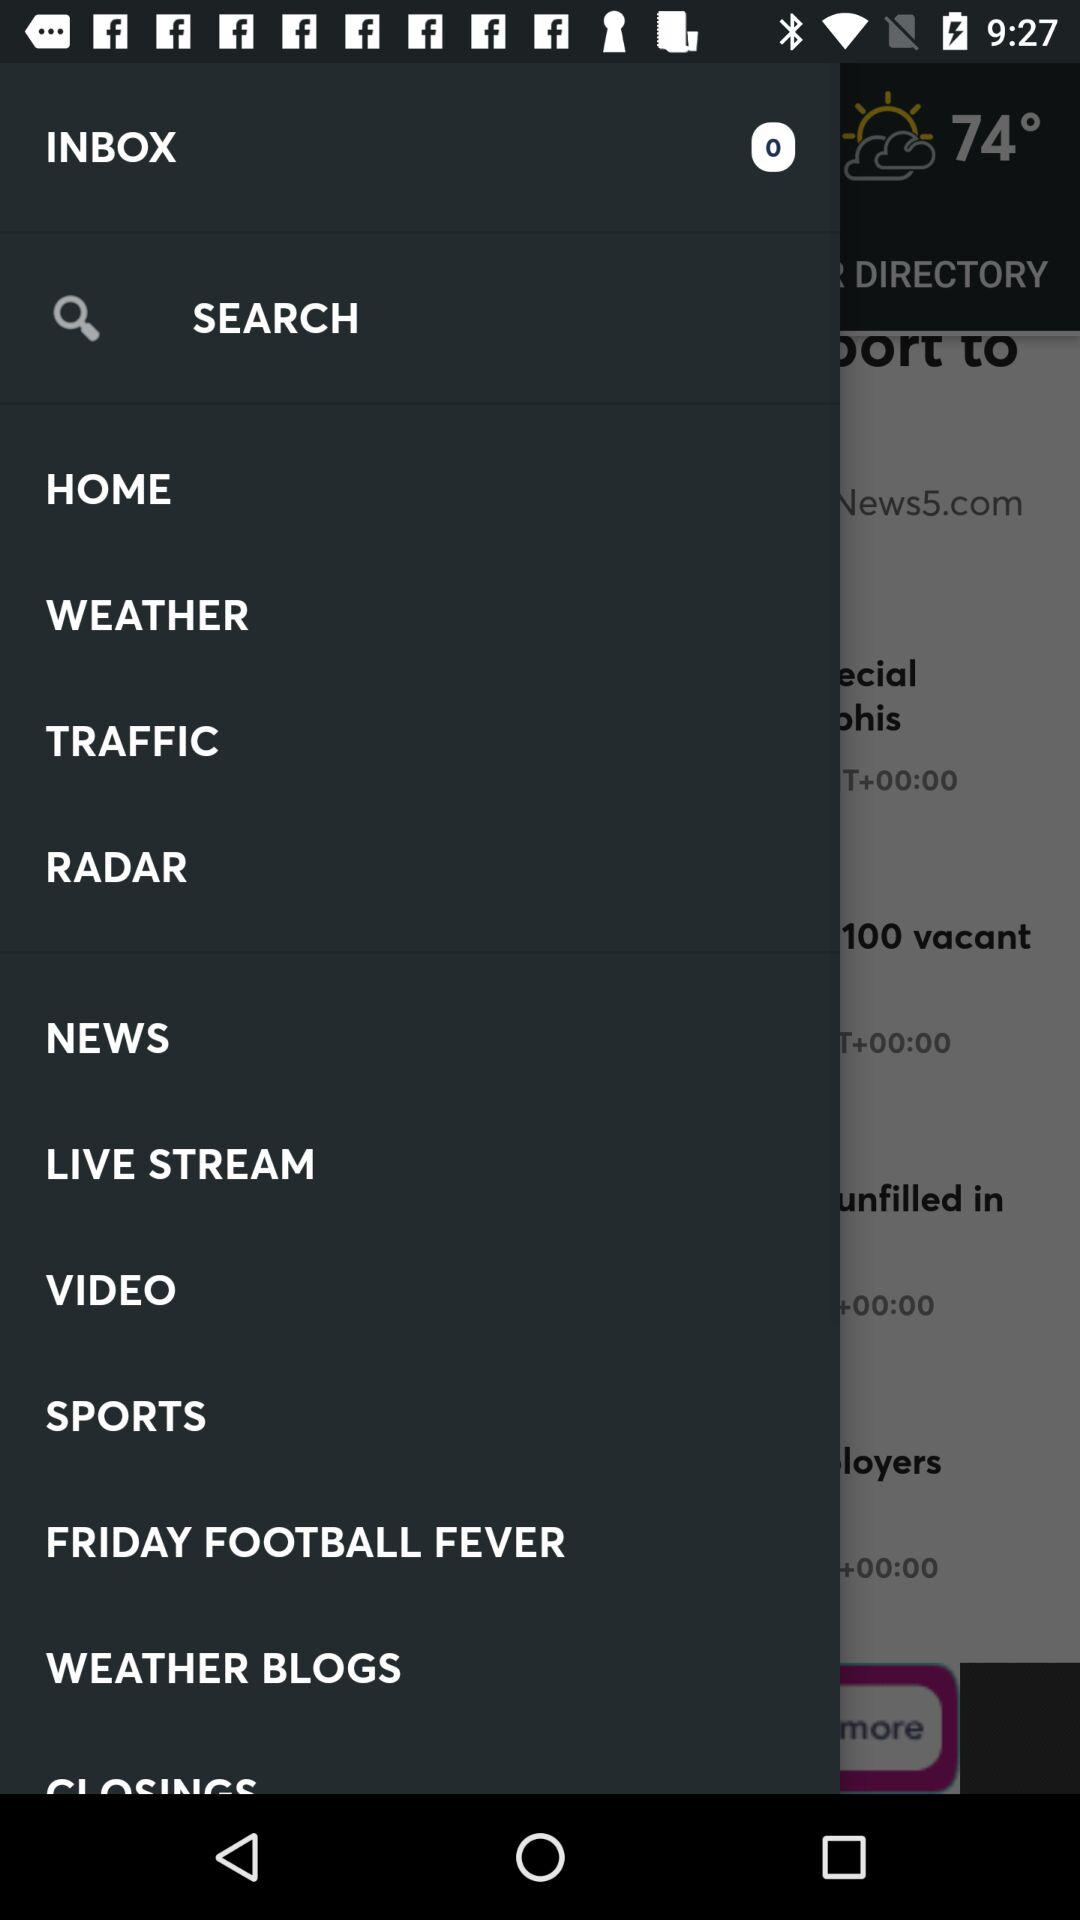What is the name of the application?
When the provided information is insufficient, respond with <no answer>. <no answer> 